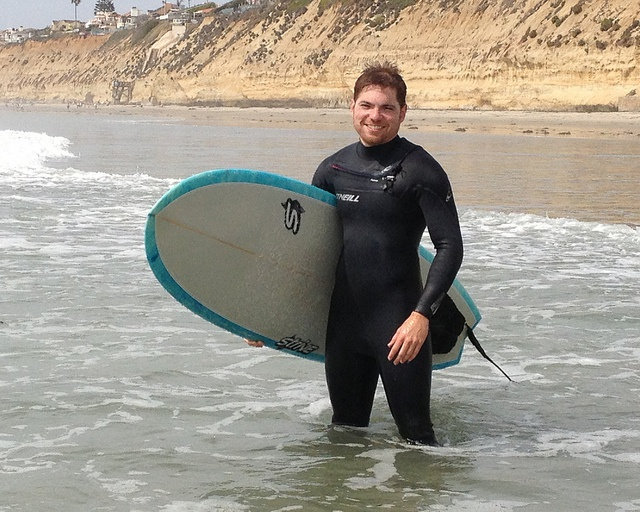Describe the objects in this image and their specific colors. I can see people in lightgray, black, gray, brown, and tan tones and surfboard in lightgray, gray, black, and teal tones in this image. 